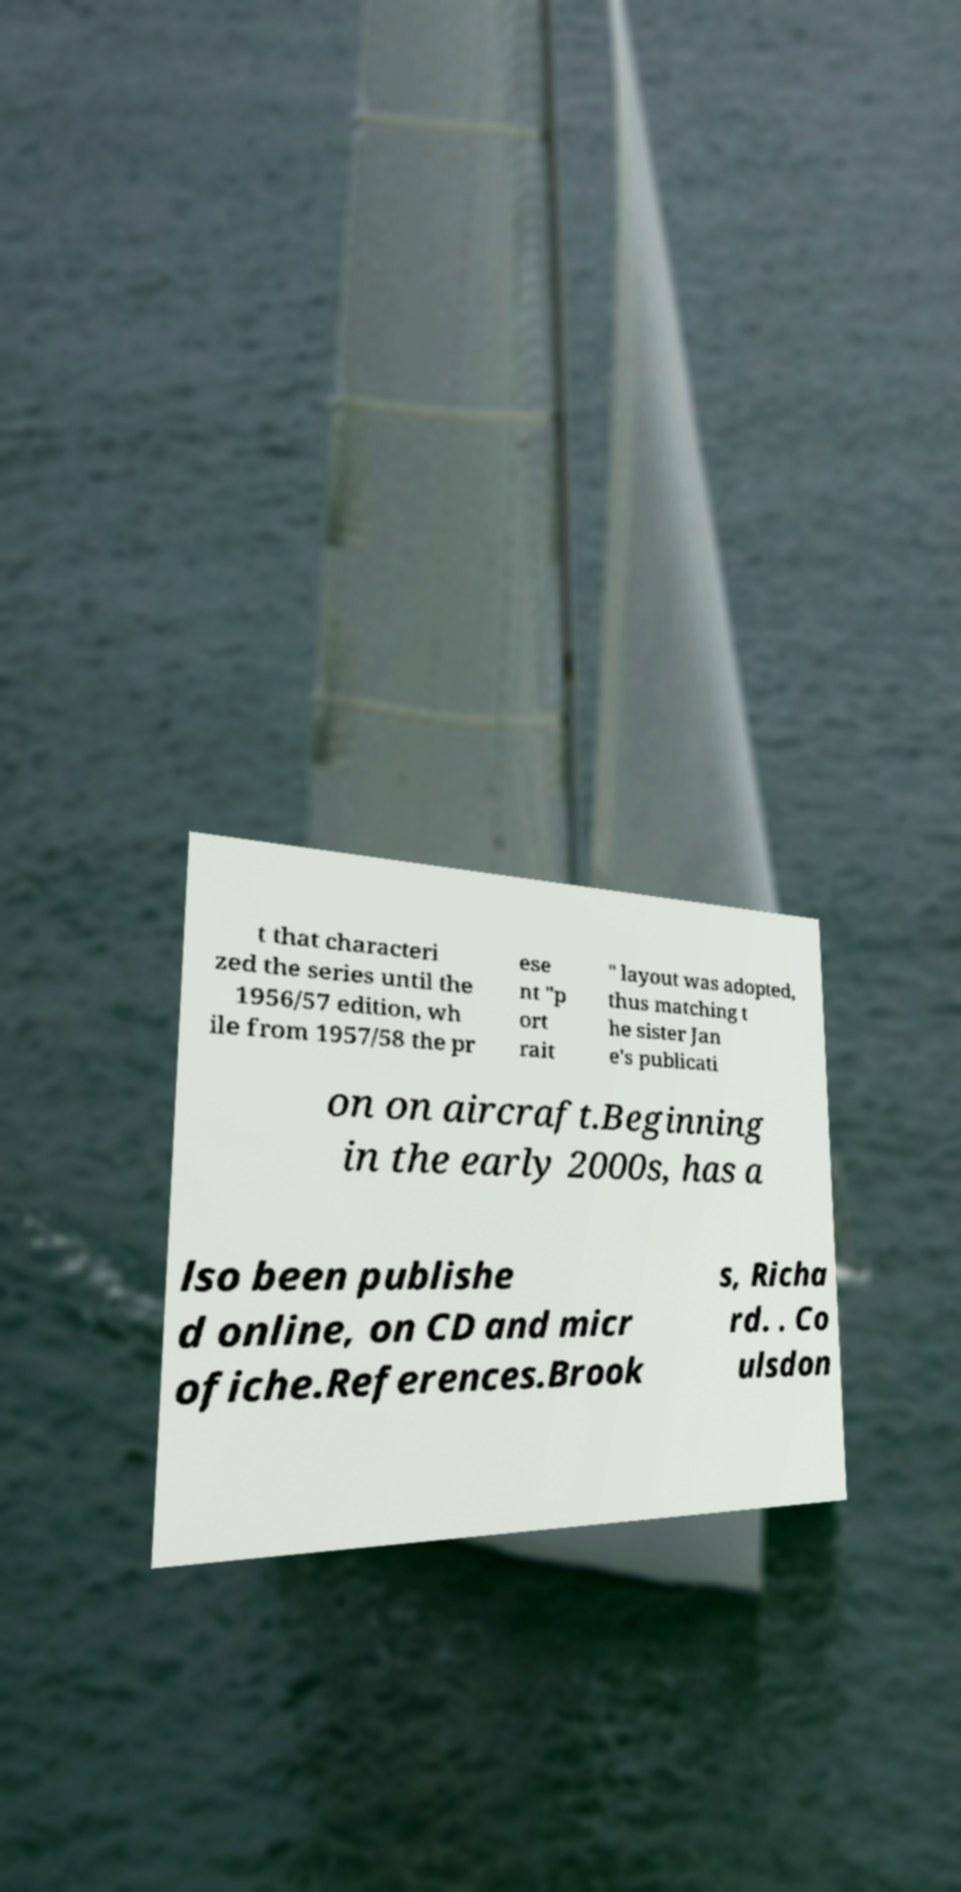What messages or text are displayed in this image? I need them in a readable, typed format. t that characteri zed the series until the 1956/57 edition, wh ile from 1957/58 the pr ese nt "p ort rait " layout was adopted, thus matching t he sister Jan e's publicati on on aircraft.Beginning in the early 2000s, has a lso been publishe d online, on CD and micr ofiche.References.Brook s, Richa rd. . Co ulsdon 